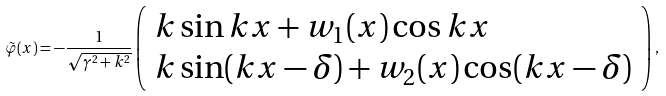<formula> <loc_0><loc_0><loc_500><loc_500>\tilde { \varphi } ( x ) = - \frac { 1 } { \sqrt { \gamma ^ { 2 } + k ^ { 2 } } } \left ( \begin{array} { l } k \sin k x + w _ { 1 } ( x ) \cos k x \\ k \sin ( k x - \delta ) + w _ { 2 } ( x ) \cos ( k x - \delta ) \end{array} \right ) \, ,</formula> 